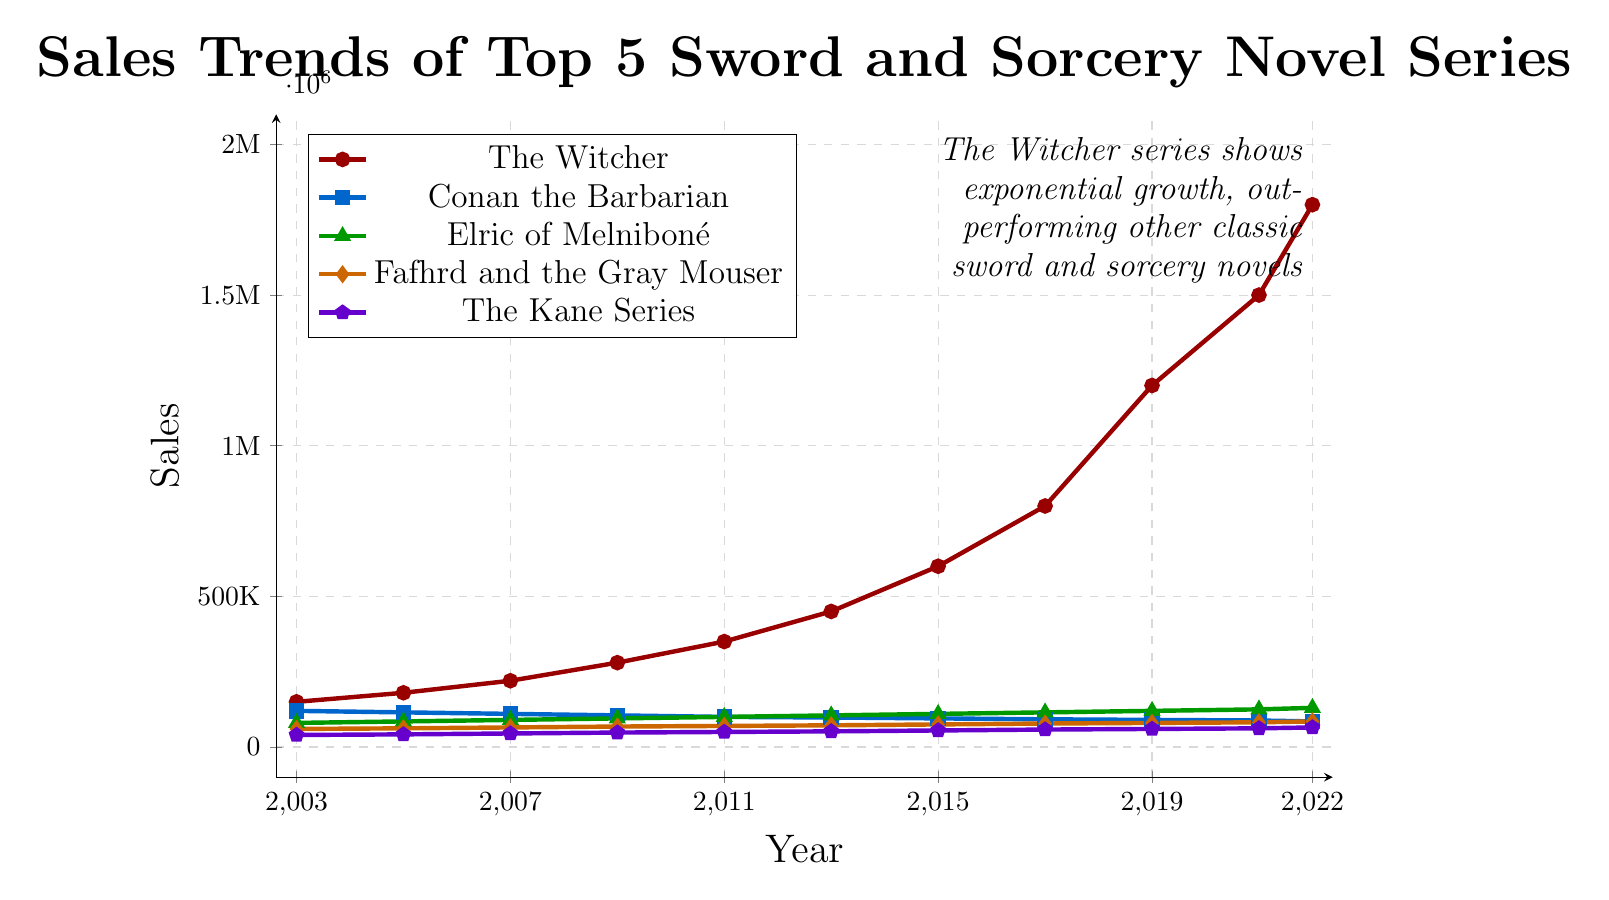What year did The Witcher series surpass 1 million in sales? In 2019, the sales for The Witcher series reached 1,200,000. By 2017, the sales were 800,000, which had not yet surpassed 1 million. Therefore, 2019 is the first year it surpassed the 1 million mark.
Answer: 2019 Among the series, which had the lowest sales in 2022? For 2022, the sales for each series are: The Witcher (1,800,000), Conan the Barbarian (85,000), Elric of Melniboné (130,000), Fafhrd and the Gray Mouser (85,000), and The Kane Series (65,000). The Kane Series had the lowest sales.
Answer: The Kane Series Which series consistently had declining sales from 2003 to 2022? By examining the data points for each series: The Witcher shows an increasing trend. Conan the Barbarian declines steadily. Elric of Melniboné, Fafhrd and the Gray Mouser, and The Kane Series all show increasing trends. Conan the Barbarian is the only series with consistent declines.
Answer: Conan the Barbarian What is the difference in sales between The Witcher and Conan the Barbarian in 2022? In 2022, The Witcher sales were 1,800,000 and Conan the Barbarian sales were 85,000. The difference is 1,800,000 - 85,000 = 1,715,000.
Answer: 1,715,000 Which series had the fastest growth rate from 2003 to 2022? The Witcher series started at 150,000 in 2003 and reached 1,800,000 in 2022. This impressive growth outpaces all other series in the graph.
Answer: The Witcher Compare the sales of Elric of Melniboné in 2003 and 2022. What is the percentage increase? Elric of Melniboné had sales of 80,000 in 2003 and 130,000 in 2022. The increase is 130,000 - 80,000 = 50,000. The percentage increase is (50,000 / 80,000) * 100% = 62.5%.
Answer: 62.5% On which years did Fafhrd and the Gray Mouser reach exactly the sales amount of The Kane Series? By comparing the data, in 2003, Fafhrd and the Gray Mouser had sales of 60,000, whereas The Kane Series had 40,000. As there are no matching exact sales figures in any year, there is no year when they had the same sales.
Answer: None Which series had the smallest increase in sales from 2003 to 2022? Comparing the sales difference across years, Conan the Barbarian started at 120,000 in 2003 and decreased to 85,000 in 2022. It had a decrease whereas all other series saw an increase, thus it had the smallest increase (actually a decrease).
Answer: Conan the Barbarian From 2003 to 2022, which two series had the closest sales values in 2017? In 2017, the sales were: The Witcher (800,000), Conan the Barbarian (92,000), Elric of Melniboné (115,000), Fafhrd and the Gray Mouser (78,000), The Kane Series (58,000). The closest sales values are Elric of Melniboné (115,000) and Conan the Barbarian (92,000).
Answer: Elric of Melniboné and Conan the Barbarian 